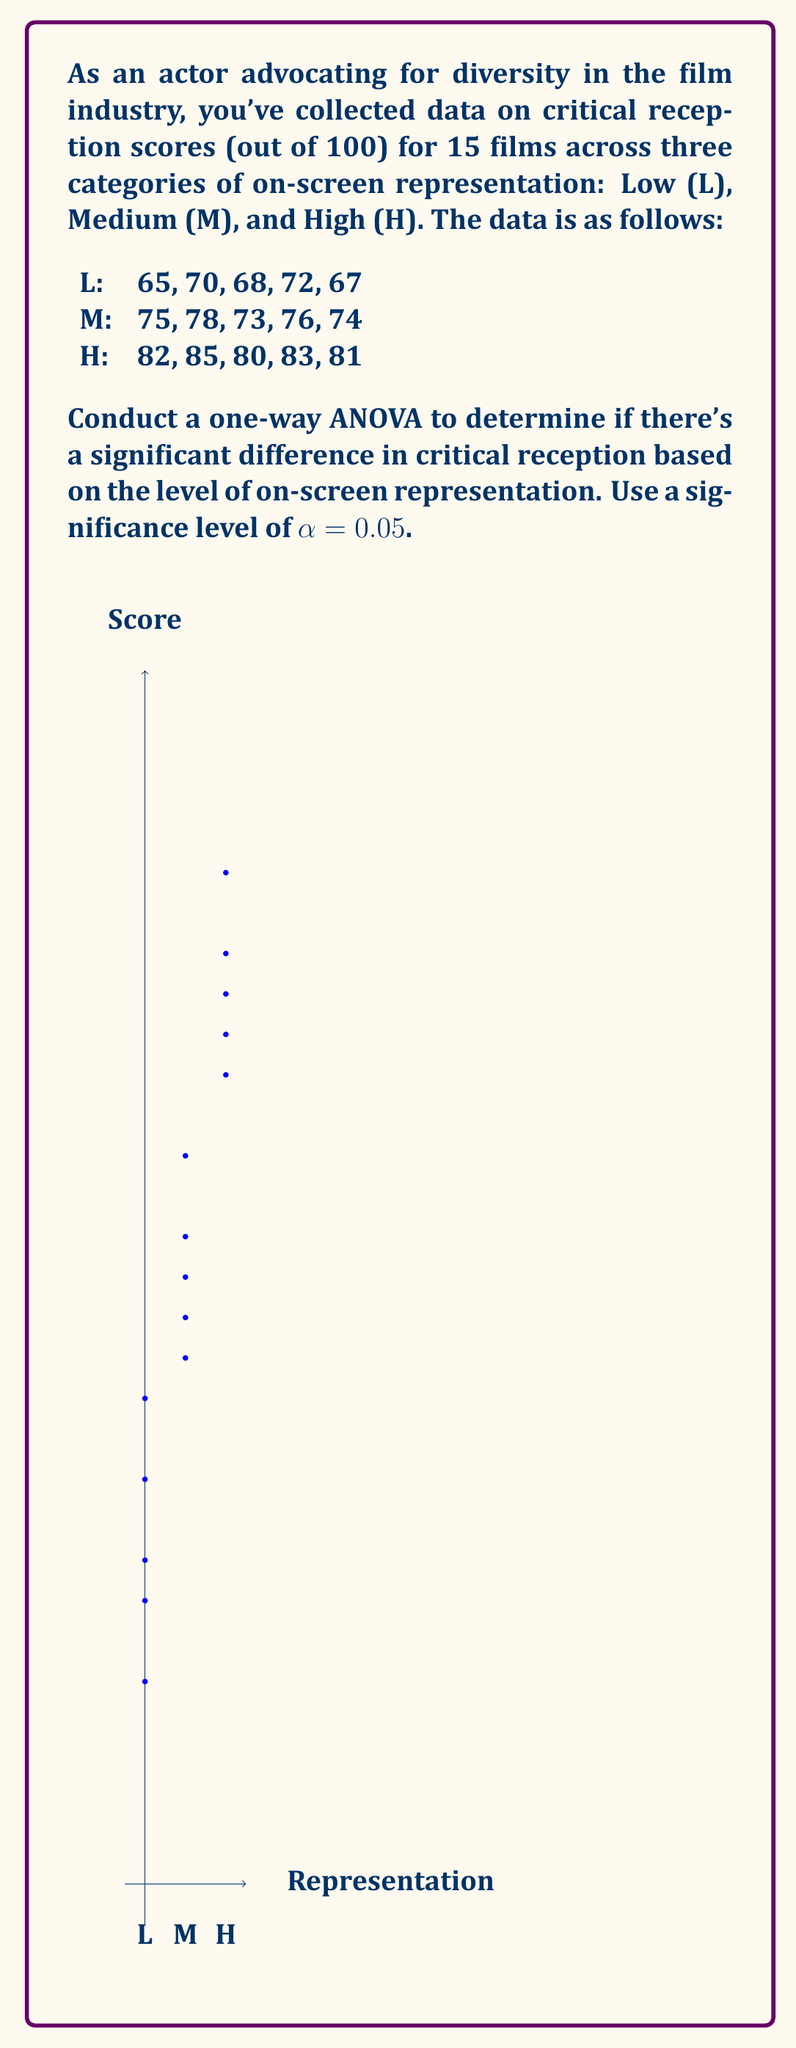What is the answer to this math problem? Let's follow the steps to conduct a one-way ANOVA:

1. Calculate the mean for each group:
   $\bar{X}_L = 68.4$, $\bar{X}_M = 75.2$, $\bar{X}_H = 82.2$

2. Calculate the grand mean:
   $\bar{X} = \frac{68.4 + 75.2 + 82.2}{3} = 75.27$

3. Calculate SS_between:
   $$SS_{between} = 5[(68.4 - 75.27)^2 + (75.2 - 75.27)^2 + (82.2 - 75.27)^2] = 595.23$$

4. Calculate SS_within:
   $$SS_{within} = \sum_{i=1}^{5}(X_{Li} - 68.4)^2 + \sum_{i=1}^{5}(X_{Mi} - 75.2)^2 + \sum_{i=1}^{5}(X_{Hi} - 82.2)^2 = 70.8$$

5. Calculate degrees of freedom:
   $df_{between} = 3 - 1 = 2$
   $df_{within} = 15 - 3 = 12$

6. Calculate Mean Square:
   $MS_{between} = \frac{SS_{between}}{df_{between}} = \frac{595.23}{2} = 297.615$
   $MS_{within} = \frac{SS_{within}}{df_{within}} = \frac{70.8}{12} = 5.9$

7. Calculate F-statistic:
   $F = \frac{MS_{between}}{MS_{within}} = \frac{297.615}{5.9} = 50.44$

8. Find the critical F-value:
   $F_{crit}(2, 12) = 3.89$ at α = 0.05

9. Compare F and F_crit:
   Since $50.44 > 3.89$, we reject the null hypothesis.

10. Calculate p-value:
    Using an F-distribution calculator, we find p < 0.0001.
Answer: $F(2,12) = 50.44, p < 0.0001$. Significant difference in critical reception based on representation levels. 